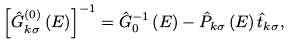Convert formula to latex. <formula><loc_0><loc_0><loc_500><loc_500>\left [ { \hat { G } _ { k \sigma } ^ { ( 0 ) } \left ( E \right ) } \right ] ^ { - 1 } = \hat { G } _ { 0 } ^ { - 1 } \left ( E \right ) - \hat { P } _ { k \sigma } \left ( E \right ) \hat { t } _ { k \sigma } ,</formula> 